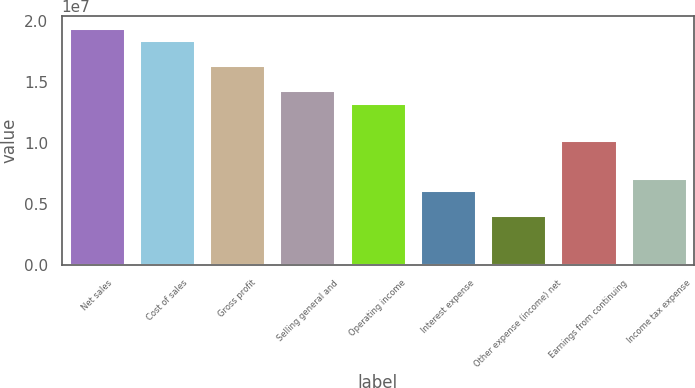Convert chart to OTSL. <chart><loc_0><loc_0><loc_500><loc_500><bar_chart><fcel>Net sales<fcel>Cost of sales<fcel>Gross profit<fcel>Selling general and<fcel>Operating income<fcel>Interest expense<fcel>Other expense (income) net<fcel>Earnings from continuing<fcel>Income tax expense<nl><fcel>1.94381e+07<fcel>1.84151e+07<fcel>1.63689e+07<fcel>1.43228e+07<fcel>1.32998e+07<fcel>6.13836e+06<fcel>4.09225e+06<fcel>1.02306e+07<fcel>7.16142e+06<nl></chart> 